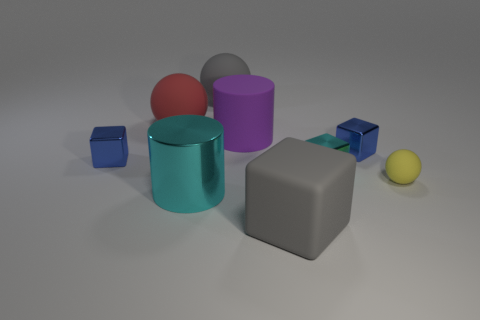Subtract all red balls. How many balls are left? 2 Subtract all purple cylinders. How many cylinders are left? 1 Subtract all red cylinders. How many blue blocks are left? 2 Subtract 2 balls. How many balls are left? 1 Subtract all cylinders. How many objects are left? 7 Add 8 gray cubes. How many gray cubes are left? 9 Add 7 big purple matte cylinders. How many big purple matte cylinders exist? 8 Subtract 0 gray cylinders. How many objects are left? 9 Subtract all green balls. Subtract all gray cylinders. How many balls are left? 3 Subtract all purple cylinders. Subtract all red rubber balls. How many objects are left? 7 